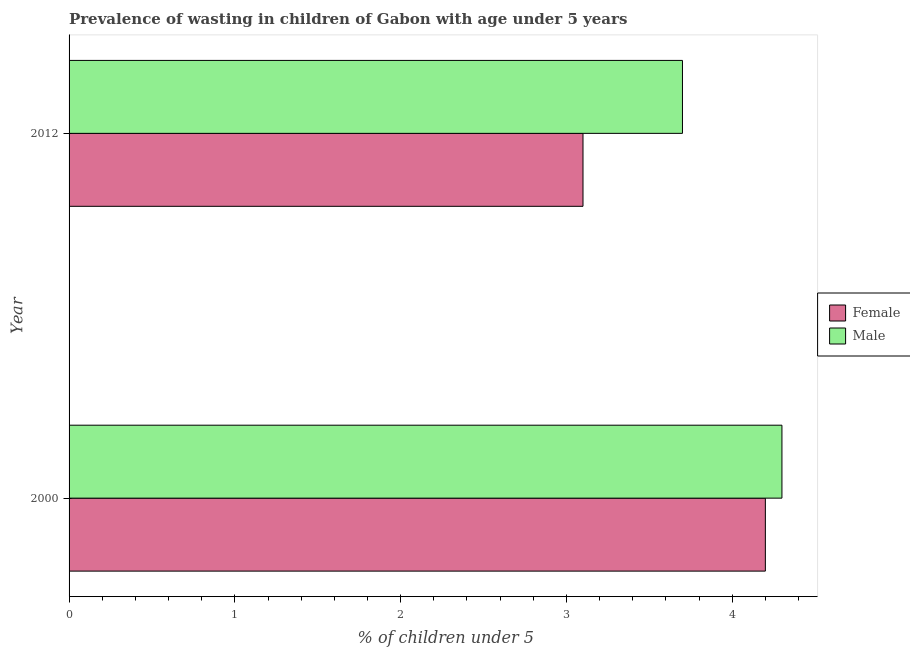How many different coloured bars are there?
Offer a terse response. 2. How many bars are there on the 2nd tick from the top?
Offer a very short reply. 2. What is the label of the 1st group of bars from the top?
Your answer should be very brief. 2012. What is the percentage of undernourished male children in 2000?
Keep it short and to the point. 4.3. Across all years, what is the maximum percentage of undernourished male children?
Offer a terse response. 4.3. Across all years, what is the minimum percentage of undernourished female children?
Your answer should be compact. 3.1. What is the total percentage of undernourished female children in the graph?
Your response must be concise. 7.3. What is the difference between the percentage of undernourished female children in 2000 and the percentage of undernourished male children in 2012?
Make the answer very short. 0.5. In the year 2000, what is the difference between the percentage of undernourished male children and percentage of undernourished female children?
Provide a short and direct response. 0.1. What is the ratio of the percentage of undernourished male children in 2000 to that in 2012?
Your answer should be compact. 1.16. Is the percentage of undernourished female children in 2000 less than that in 2012?
Ensure brevity in your answer.  No. Is the difference between the percentage of undernourished male children in 2000 and 2012 greater than the difference between the percentage of undernourished female children in 2000 and 2012?
Keep it short and to the point. No. What does the 1st bar from the top in 2000 represents?
Offer a very short reply. Male. Are all the bars in the graph horizontal?
Your response must be concise. Yes. How many years are there in the graph?
Offer a terse response. 2. Are the values on the major ticks of X-axis written in scientific E-notation?
Your answer should be compact. No. Does the graph contain any zero values?
Offer a terse response. No. Does the graph contain grids?
Ensure brevity in your answer.  No. How many legend labels are there?
Ensure brevity in your answer.  2. What is the title of the graph?
Make the answer very short. Prevalence of wasting in children of Gabon with age under 5 years. What is the label or title of the X-axis?
Make the answer very short.  % of children under 5. What is the  % of children under 5 of Female in 2000?
Your answer should be compact. 4.2. What is the  % of children under 5 of Male in 2000?
Provide a short and direct response. 4.3. What is the  % of children under 5 in Female in 2012?
Offer a terse response. 3.1. What is the  % of children under 5 in Male in 2012?
Keep it short and to the point. 3.7. Across all years, what is the maximum  % of children under 5 of Female?
Ensure brevity in your answer.  4.2. Across all years, what is the maximum  % of children under 5 in Male?
Give a very brief answer. 4.3. Across all years, what is the minimum  % of children under 5 of Female?
Your response must be concise. 3.1. Across all years, what is the minimum  % of children under 5 in Male?
Keep it short and to the point. 3.7. What is the total  % of children under 5 of Female in the graph?
Your answer should be compact. 7.3. What is the total  % of children under 5 of Male in the graph?
Offer a terse response. 8. What is the difference between the  % of children under 5 of Female in 2000 and that in 2012?
Your answer should be compact. 1.1. What is the difference between the  % of children under 5 in Male in 2000 and that in 2012?
Your answer should be very brief. 0.6. What is the average  % of children under 5 in Female per year?
Make the answer very short. 3.65. In the year 2012, what is the difference between the  % of children under 5 in Female and  % of children under 5 in Male?
Provide a short and direct response. -0.6. What is the ratio of the  % of children under 5 in Female in 2000 to that in 2012?
Your response must be concise. 1.35. What is the ratio of the  % of children under 5 in Male in 2000 to that in 2012?
Ensure brevity in your answer.  1.16. What is the difference between the highest and the second highest  % of children under 5 of Female?
Your response must be concise. 1.1. What is the difference between the highest and the second highest  % of children under 5 of Male?
Make the answer very short. 0.6. What is the difference between the highest and the lowest  % of children under 5 in Female?
Provide a short and direct response. 1.1. What is the difference between the highest and the lowest  % of children under 5 of Male?
Your answer should be compact. 0.6. 